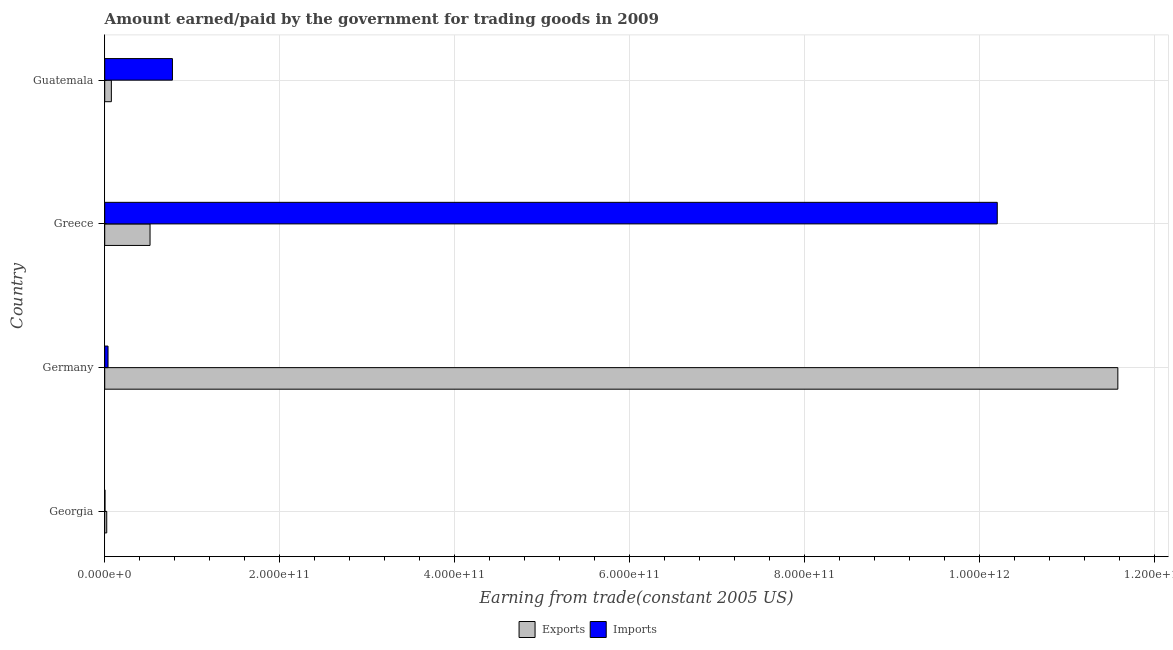How many groups of bars are there?
Give a very brief answer. 4. Are the number of bars on each tick of the Y-axis equal?
Ensure brevity in your answer.  Yes. How many bars are there on the 3rd tick from the bottom?
Keep it short and to the point. 2. What is the label of the 1st group of bars from the top?
Your answer should be very brief. Guatemala. In how many cases, is the number of bars for a given country not equal to the number of legend labels?
Your answer should be compact. 0. What is the amount earned from exports in Guatemala?
Give a very brief answer. 7.60e+09. Across all countries, what is the maximum amount paid for imports?
Your answer should be compact. 1.02e+12. Across all countries, what is the minimum amount earned from exports?
Offer a terse response. 2.31e+09. In which country was the amount earned from exports maximum?
Give a very brief answer. Germany. In which country was the amount earned from exports minimum?
Offer a terse response. Georgia. What is the total amount paid for imports in the graph?
Your answer should be very brief. 1.10e+12. What is the difference between the amount paid for imports in Germany and that in Guatemala?
Ensure brevity in your answer.  -7.36e+1. What is the difference between the amount paid for imports in Guatemala and the amount earned from exports in Germany?
Your answer should be compact. -1.08e+12. What is the average amount paid for imports per country?
Your answer should be compact. 2.75e+11. What is the difference between the amount paid for imports and amount earned from exports in Germany?
Make the answer very short. -1.15e+12. What is the ratio of the amount earned from exports in Georgia to that in Greece?
Provide a succinct answer. 0.04. Is the amount paid for imports in Germany less than that in Greece?
Give a very brief answer. Yes. What is the difference between the highest and the second highest amount paid for imports?
Ensure brevity in your answer.  9.43e+11. What is the difference between the highest and the lowest amount earned from exports?
Give a very brief answer. 1.16e+12. Is the sum of the amount earned from exports in Georgia and Greece greater than the maximum amount paid for imports across all countries?
Make the answer very short. No. What does the 2nd bar from the top in Greece represents?
Your response must be concise. Exports. What does the 2nd bar from the bottom in Georgia represents?
Ensure brevity in your answer.  Imports. How many bars are there?
Offer a terse response. 8. Are all the bars in the graph horizontal?
Offer a very short reply. Yes. What is the difference between two consecutive major ticks on the X-axis?
Ensure brevity in your answer.  2.00e+11. Are the values on the major ticks of X-axis written in scientific E-notation?
Your answer should be compact. Yes. Where does the legend appear in the graph?
Keep it short and to the point. Bottom center. What is the title of the graph?
Your answer should be compact. Amount earned/paid by the government for trading goods in 2009. What is the label or title of the X-axis?
Provide a succinct answer. Earning from trade(constant 2005 US). What is the Earning from trade(constant 2005 US) of Exports in Georgia?
Offer a terse response. 2.31e+09. What is the Earning from trade(constant 2005 US) of Imports in Georgia?
Offer a terse response. 3.07e+08. What is the Earning from trade(constant 2005 US) of Exports in Germany?
Give a very brief answer. 1.16e+12. What is the Earning from trade(constant 2005 US) of Imports in Germany?
Give a very brief answer. 3.80e+09. What is the Earning from trade(constant 2005 US) of Exports in Greece?
Offer a very short reply. 5.18e+1. What is the Earning from trade(constant 2005 US) of Imports in Greece?
Offer a terse response. 1.02e+12. What is the Earning from trade(constant 2005 US) in Exports in Guatemala?
Your answer should be compact. 7.60e+09. What is the Earning from trade(constant 2005 US) in Imports in Guatemala?
Give a very brief answer. 7.74e+1. Across all countries, what is the maximum Earning from trade(constant 2005 US) in Exports?
Your answer should be compact. 1.16e+12. Across all countries, what is the maximum Earning from trade(constant 2005 US) of Imports?
Provide a succinct answer. 1.02e+12. Across all countries, what is the minimum Earning from trade(constant 2005 US) in Exports?
Your response must be concise. 2.31e+09. Across all countries, what is the minimum Earning from trade(constant 2005 US) in Imports?
Ensure brevity in your answer.  3.07e+08. What is the total Earning from trade(constant 2005 US) in Exports in the graph?
Your response must be concise. 1.22e+12. What is the total Earning from trade(constant 2005 US) of Imports in the graph?
Keep it short and to the point. 1.10e+12. What is the difference between the Earning from trade(constant 2005 US) of Exports in Georgia and that in Germany?
Offer a very short reply. -1.16e+12. What is the difference between the Earning from trade(constant 2005 US) in Imports in Georgia and that in Germany?
Offer a terse response. -3.49e+09. What is the difference between the Earning from trade(constant 2005 US) in Exports in Georgia and that in Greece?
Keep it short and to the point. -4.95e+1. What is the difference between the Earning from trade(constant 2005 US) in Imports in Georgia and that in Greece?
Give a very brief answer. -1.02e+12. What is the difference between the Earning from trade(constant 2005 US) in Exports in Georgia and that in Guatemala?
Ensure brevity in your answer.  -5.29e+09. What is the difference between the Earning from trade(constant 2005 US) of Imports in Georgia and that in Guatemala?
Offer a very short reply. -7.71e+1. What is the difference between the Earning from trade(constant 2005 US) of Exports in Germany and that in Greece?
Your answer should be compact. 1.11e+12. What is the difference between the Earning from trade(constant 2005 US) of Imports in Germany and that in Greece?
Your response must be concise. -1.02e+12. What is the difference between the Earning from trade(constant 2005 US) of Exports in Germany and that in Guatemala?
Make the answer very short. 1.15e+12. What is the difference between the Earning from trade(constant 2005 US) of Imports in Germany and that in Guatemala?
Offer a terse response. -7.36e+1. What is the difference between the Earning from trade(constant 2005 US) in Exports in Greece and that in Guatemala?
Your answer should be very brief. 4.42e+1. What is the difference between the Earning from trade(constant 2005 US) in Imports in Greece and that in Guatemala?
Your answer should be very brief. 9.43e+11. What is the difference between the Earning from trade(constant 2005 US) in Exports in Georgia and the Earning from trade(constant 2005 US) in Imports in Germany?
Offer a very short reply. -1.49e+09. What is the difference between the Earning from trade(constant 2005 US) in Exports in Georgia and the Earning from trade(constant 2005 US) in Imports in Greece?
Make the answer very short. -1.02e+12. What is the difference between the Earning from trade(constant 2005 US) in Exports in Georgia and the Earning from trade(constant 2005 US) in Imports in Guatemala?
Offer a terse response. -7.51e+1. What is the difference between the Earning from trade(constant 2005 US) of Exports in Germany and the Earning from trade(constant 2005 US) of Imports in Greece?
Provide a short and direct response. 1.38e+11. What is the difference between the Earning from trade(constant 2005 US) in Exports in Germany and the Earning from trade(constant 2005 US) in Imports in Guatemala?
Ensure brevity in your answer.  1.08e+12. What is the difference between the Earning from trade(constant 2005 US) of Exports in Greece and the Earning from trade(constant 2005 US) of Imports in Guatemala?
Offer a very short reply. -2.56e+1. What is the average Earning from trade(constant 2005 US) of Exports per country?
Provide a succinct answer. 3.05e+11. What is the average Earning from trade(constant 2005 US) in Imports per country?
Keep it short and to the point. 2.75e+11. What is the difference between the Earning from trade(constant 2005 US) in Exports and Earning from trade(constant 2005 US) in Imports in Georgia?
Your answer should be very brief. 2.00e+09. What is the difference between the Earning from trade(constant 2005 US) of Exports and Earning from trade(constant 2005 US) of Imports in Germany?
Offer a terse response. 1.15e+12. What is the difference between the Earning from trade(constant 2005 US) of Exports and Earning from trade(constant 2005 US) of Imports in Greece?
Provide a short and direct response. -9.69e+11. What is the difference between the Earning from trade(constant 2005 US) of Exports and Earning from trade(constant 2005 US) of Imports in Guatemala?
Give a very brief answer. -6.98e+1. What is the ratio of the Earning from trade(constant 2005 US) in Exports in Georgia to that in Germany?
Keep it short and to the point. 0. What is the ratio of the Earning from trade(constant 2005 US) of Imports in Georgia to that in Germany?
Keep it short and to the point. 0.08. What is the ratio of the Earning from trade(constant 2005 US) of Exports in Georgia to that in Greece?
Provide a succinct answer. 0.04. What is the ratio of the Earning from trade(constant 2005 US) of Imports in Georgia to that in Greece?
Offer a terse response. 0. What is the ratio of the Earning from trade(constant 2005 US) in Exports in Georgia to that in Guatemala?
Your answer should be very brief. 0.3. What is the ratio of the Earning from trade(constant 2005 US) in Imports in Georgia to that in Guatemala?
Keep it short and to the point. 0. What is the ratio of the Earning from trade(constant 2005 US) in Exports in Germany to that in Greece?
Keep it short and to the point. 22.35. What is the ratio of the Earning from trade(constant 2005 US) of Imports in Germany to that in Greece?
Your answer should be very brief. 0. What is the ratio of the Earning from trade(constant 2005 US) in Exports in Germany to that in Guatemala?
Ensure brevity in your answer.  152.48. What is the ratio of the Earning from trade(constant 2005 US) of Imports in Germany to that in Guatemala?
Ensure brevity in your answer.  0.05. What is the ratio of the Earning from trade(constant 2005 US) of Exports in Greece to that in Guatemala?
Give a very brief answer. 6.82. What is the ratio of the Earning from trade(constant 2005 US) of Imports in Greece to that in Guatemala?
Ensure brevity in your answer.  13.18. What is the difference between the highest and the second highest Earning from trade(constant 2005 US) in Exports?
Make the answer very short. 1.11e+12. What is the difference between the highest and the second highest Earning from trade(constant 2005 US) in Imports?
Make the answer very short. 9.43e+11. What is the difference between the highest and the lowest Earning from trade(constant 2005 US) in Exports?
Offer a very short reply. 1.16e+12. What is the difference between the highest and the lowest Earning from trade(constant 2005 US) of Imports?
Offer a very short reply. 1.02e+12. 